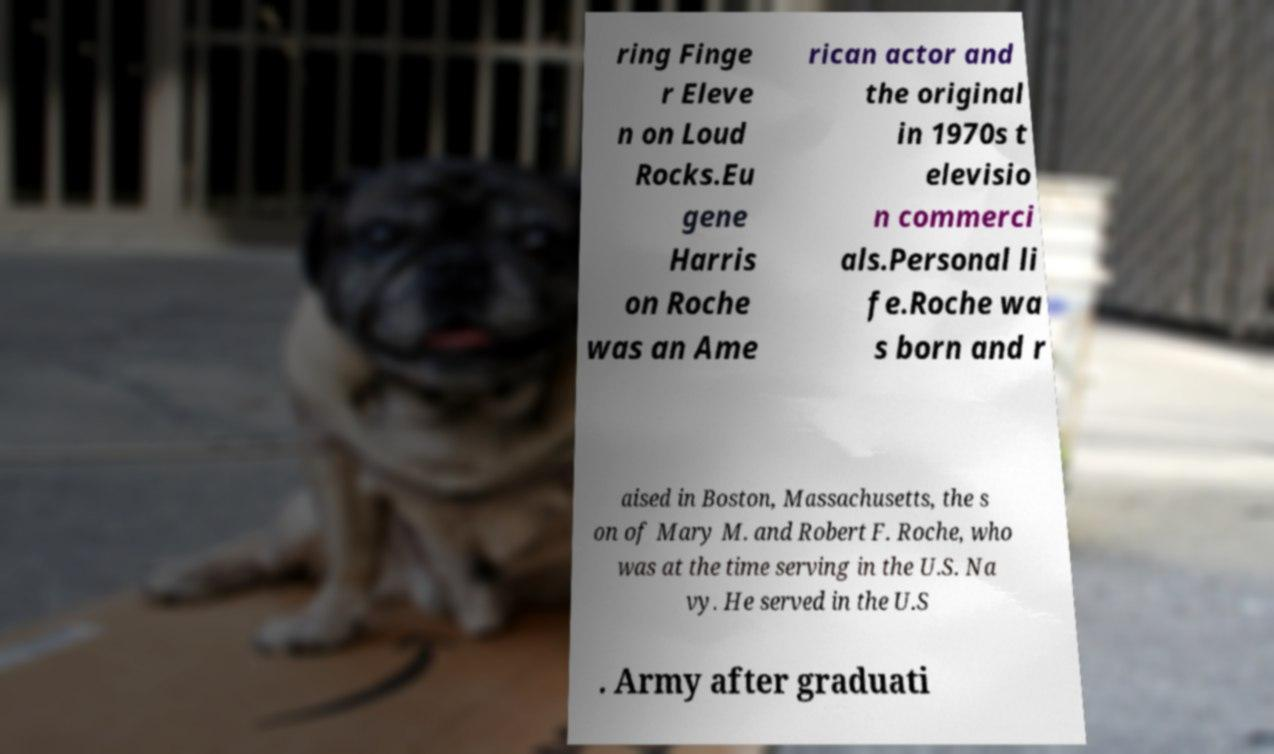What messages or text are displayed in this image? I need them in a readable, typed format. ring Finge r Eleve n on Loud Rocks.Eu gene Harris on Roche was an Ame rican actor and the original in 1970s t elevisio n commerci als.Personal li fe.Roche wa s born and r aised in Boston, Massachusetts, the s on of Mary M. and Robert F. Roche, who was at the time serving in the U.S. Na vy. He served in the U.S . Army after graduati 